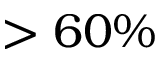Convert formula to latex. <formula><loc_0><loc_0><loc_500><loc_500>> 6 0 \%</formula> 